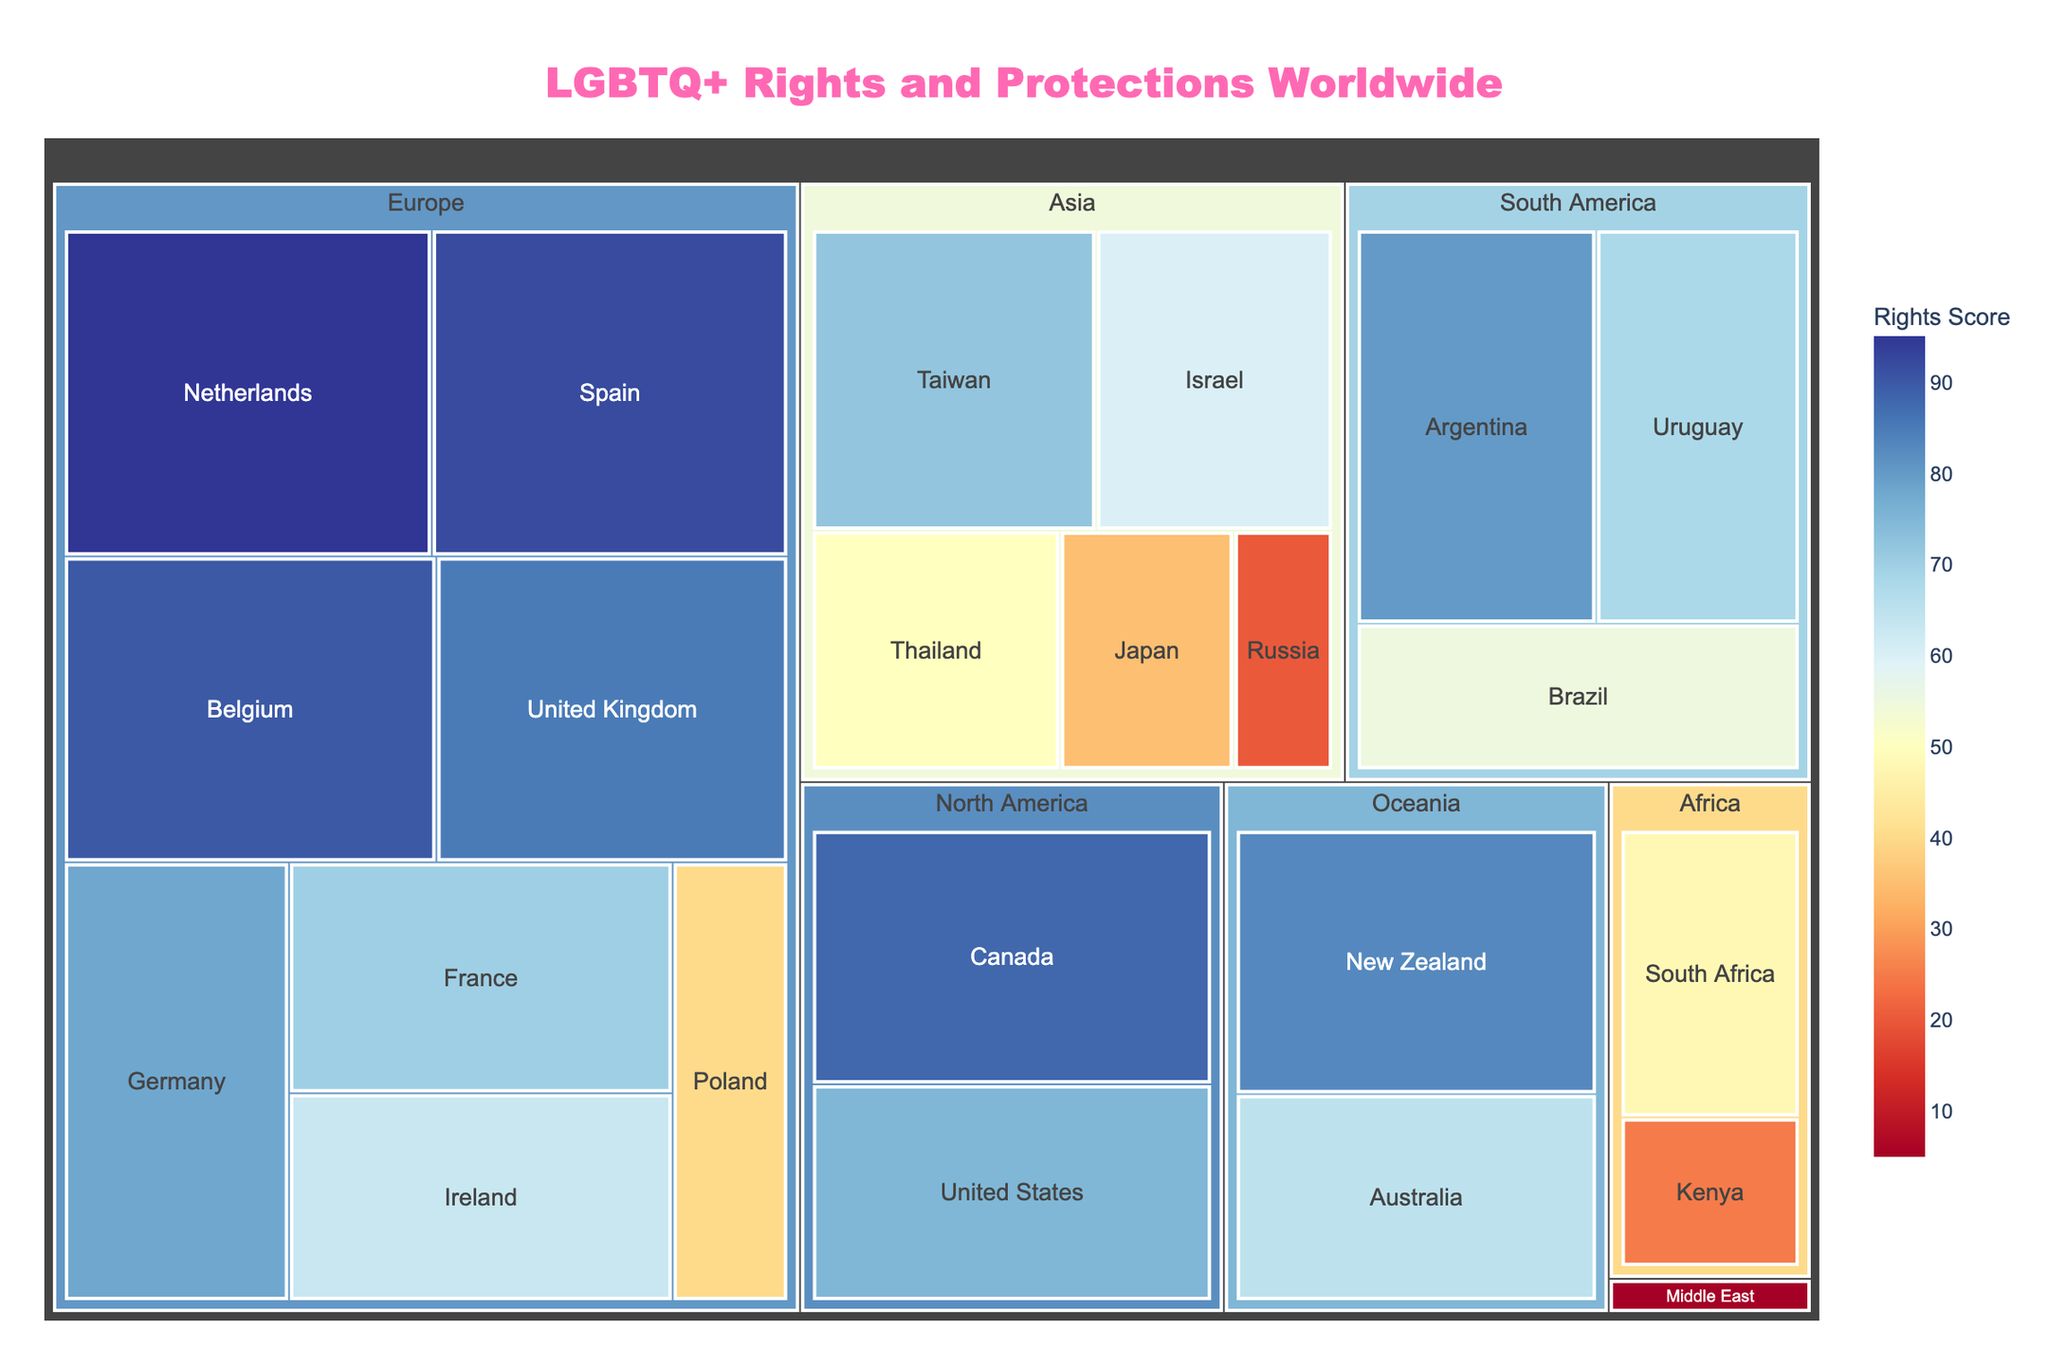What's the title of the figure? The title of the figure is shown at the top in a larger font and different color. It states the main topic of the treemap, which is "LGBTQ+ Rights and Protections Worldwide".
Answer: LGBTQ+ Rights and Protections Worldwide Which country in Europe has the highest Rights Score? By examining the regions within the treemap and focusing on Europe, the country with the highest value (largest area and brightest color) is the Netherlands with a Rights Score of 95.
Answer: Netherlands How many countries are displayed in the North America region? By counting the individual country blocks within the North America section of the treemap, we can see there are two countries listed: Canada and the United States.
Answer: 2 What's the average Rights Score for the countries in the Asia region? The Rights Scores for the countries in Asia are Taiwan (72), Israel (60), Thailand (50), Japan (35), and Russia (20). Calculating the average: (72 + 60 + 50 + 35 + 20) / 5 = 237 / 5 = 47.4.
Answer: 47.4 Which country has the lowest Rights Score, and what is it? The treemap shows different shades representing Rights Scores. The country with the smallest area and darkest color is Saudi Arabia in the Middle East region, with a Rights Score of 5.
Answer: Saudi Arabia with a Rights Score of 5 Compare the Rights Scores of South Africa and Poland. Which has a higher score? In the Africa and Europe regions of the treemap, South Africa has a score of 48 whereas Poland has a score of 40. Hence, South Africa has a higher Rights Score than Poland.
Answer: South Africa What is the range of Rights Scores in the South America region? The South America countries shown in the treemap are Argentina (80), Uruguay (68), and Brazil (55). The range is the difference between the highest and lowest scores: 80 - 55 = 25.
Answer: 25 Which region contains the country with the lowest Rights Score, and what is that country? By observing the segments in the treemap, the Middle East region contains the country with the lowest Rights Score, which is Saudi Arabia with a score of 5.
Answer: Middle East; Saudi Arabia What's the median Rights Score of all the countries listed in the treemap? First, list all the scores in increasing order:
5, 20, 25, 35, 40, 48, 50, 55, 60, 63, 65, 68, 70, 72, 75, 78, 80, 83, 85, 88, 90, 92, 95. There are 23 values, so the median is the 12th value: 68.
Answer: 68 